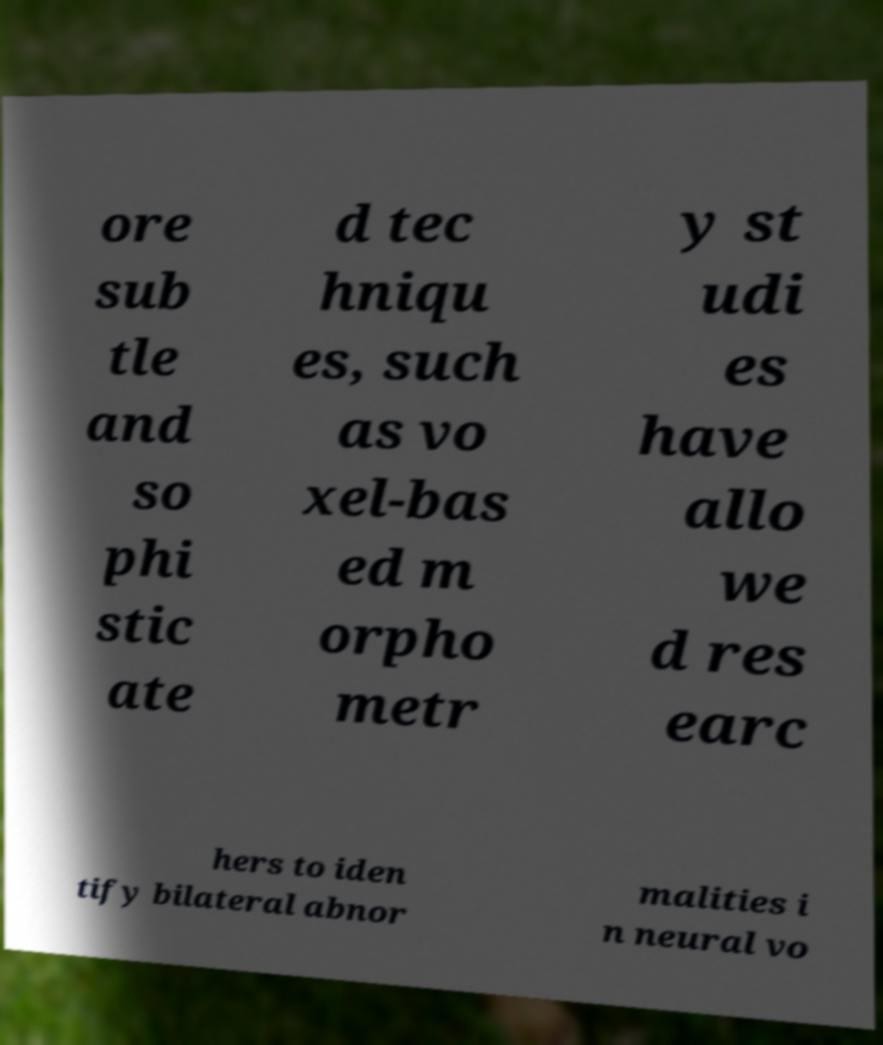Please read and relay the text visible in this image. What does it say? ore sub tle and so phi stic ate d tec hniqu es, such as vo xel-bas ed m orpho metr y st udi es have allo we d res earc hers to iden tify bilateral abnor malities i n neural vo 